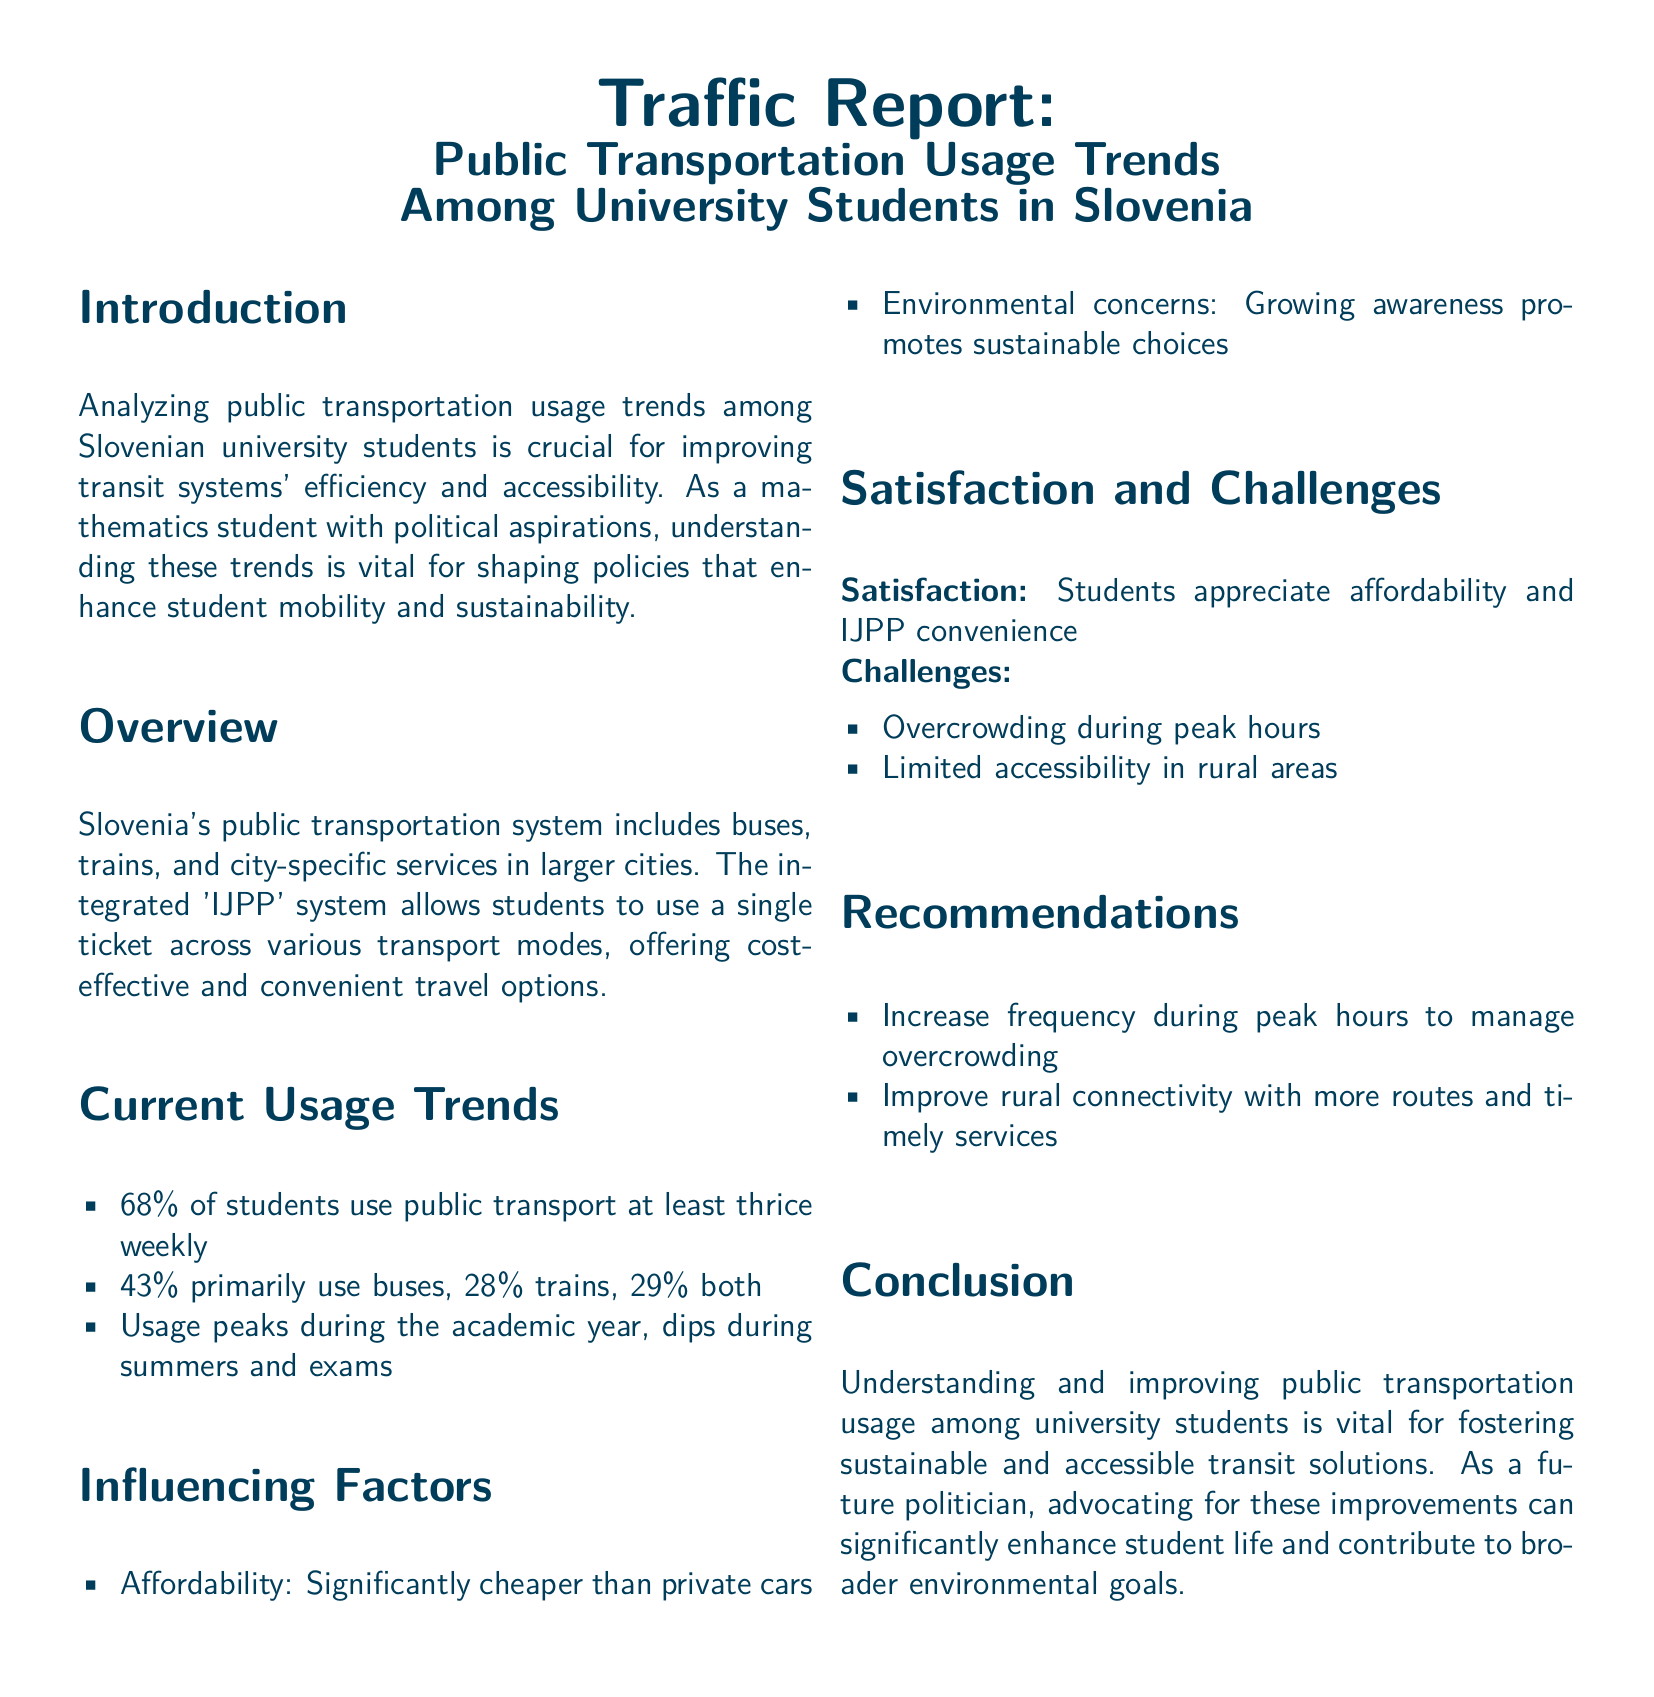what percentage of students use public transport at least thrice weekly? The document states that 68% of students use public transport at least thrice weekly.
Answer: 68% which transportation mode is primarily used by 43% of students? The report indicates that 43% of students primarily use buses.
Answer: buses what is the primary reason for the rising public transport usage among students? The document lists affordability as a significant factor influencing usage, being cheaper than private cars.
Answer: Affordability during which time periods does public transportation usage significantly dip? According to the report, usage dips during summers and exams.
Answer: summers and exams what is one of the main challenges students face regarding public transportation? The document outlines overcrowding during peak hours as a key challenge faced by students.
Answer: Overcrowding what recommendation is made to improve rural connectivity? The report suggests improving rural connectivity with more routes and timely services.
Answer: More routes and timely services what integrated system allows students to use a single ticket? The document mentions the 'IJPP' system as the integrated system for students.
Answer: IJPP what percentage of students use both buses and trains? The document states that 29% of students use both buses and trains.
Answer: 29% 